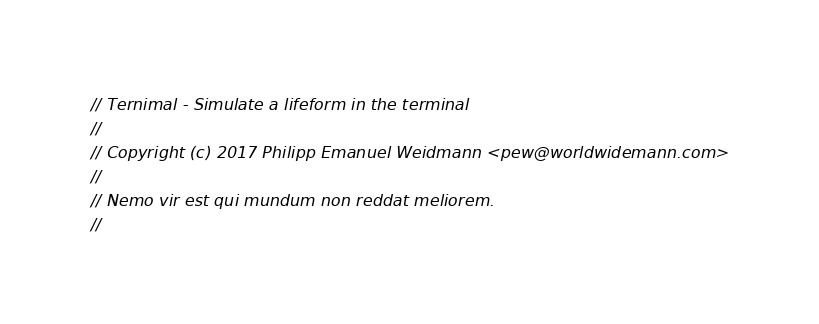<code> <loc_0><loc_0><loc_500><loc_500><_Rust_>// Ternimal - Simulate a lifeform in the terminal
//
// Copyright (c) 2017 Philipp Emanuel Weidmann <pew@worldwidemann.com>
//
// Nemo vir est qui mundum non reddat meliorem.
//</code> 